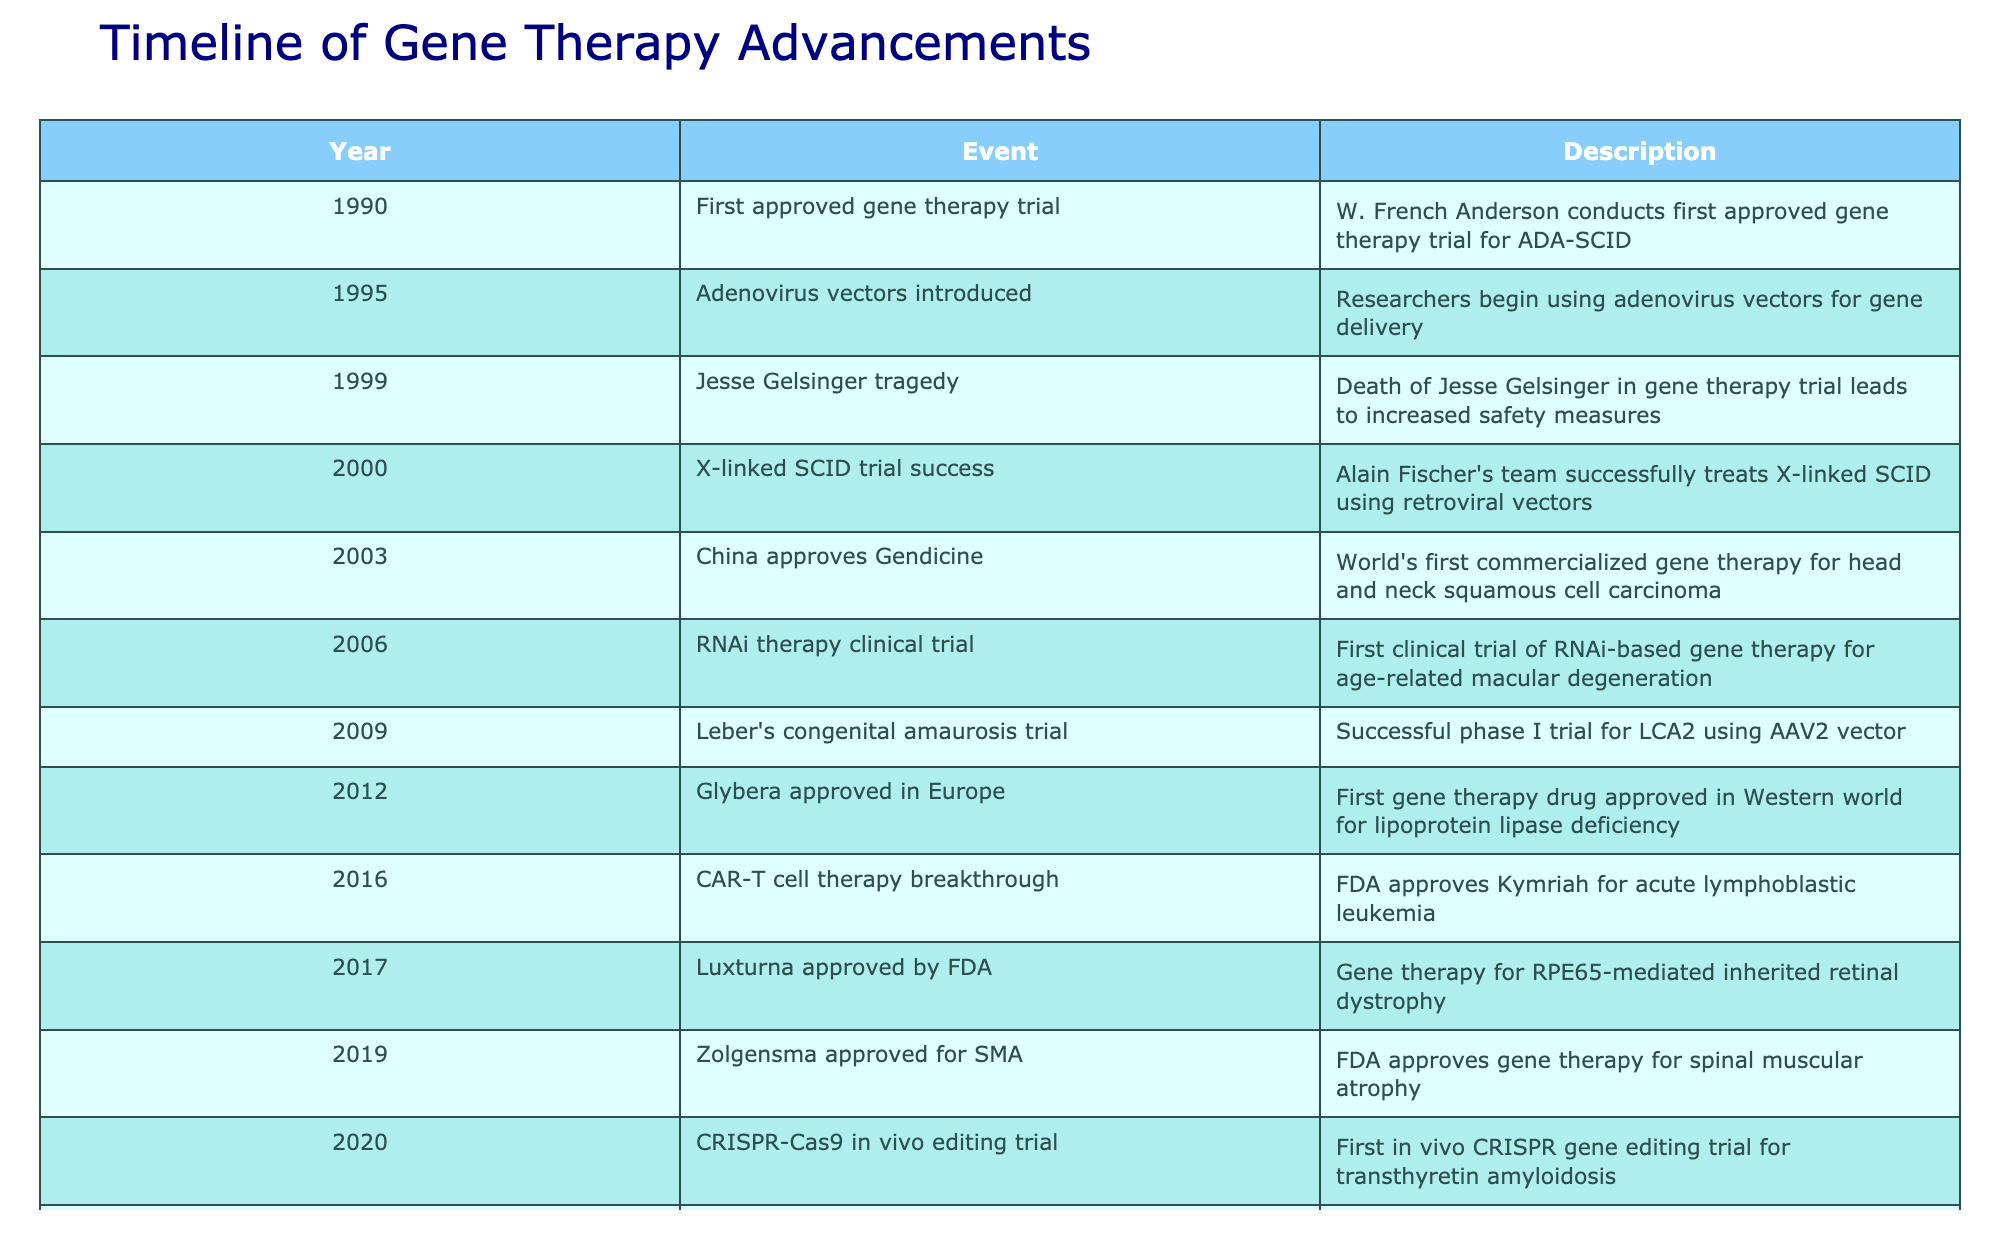What year did the first approved gene therapy trial occur? The first approved gene therapy trial occurred in 1990, as indicated in the table under the "Year" column associated with the event "First approved gene therapy trial."
Answer: 1990 Which gene therapy for retinal dystrophy was approved by the FDA in 2017? The gene therapy for RPE65-mediated inherited retinal dystrophy approved by the FDA in 2017 is Luxturna. This can be found by locating the entry for 2017 in the "Event" column.
Answer: Luxturna How many gene therapies were approved by the FDA between 2016 and 2023? From 2016 to 2023, four gene therapies were approved by the FDA: Kymriah (2016), Luxturna (2017), Zolgensma (2019), and Hemgenix (2022). Counting these events provides the total.
Answer: 4 What is the difference in years between the first gene therapy trial and the approval of the first commercialized gene therapy? The first approved gene therapy trial occurred in 1990, and the first commercialized gene therapy (Gendicine) was approved in 2003. The difference is calculated as 2003 - 1990 = 13 years.
Answer: 13 years Was there a gene therapy clinical trial for RNA interference (RNAi) before 2010? Yes, the first clinical trial of RNAi-based gene therapy for age-related macular degeneration occurred in 2006, which is before 2010. This can be confirmed by locating the relevant entry in the table.
Answer: Yes Which gene therapy was developed using a CRISPR technology and what was the trial's focus? The gene therapy developed using CRISPR technology is for transthyretin amyloidosis, and the trial was initiated in 2020, as indicated by examining the relevant row in the table.
Answer: Transthyretin amyloidosis What is the chronological order of gene therapy approvals from 2017 to 2023? The chronological order from 2017 to 2023 is: 2017 - Luxturna, 2019 - Zolgensma, 2022 - Hemgenix, and finally 2023 - BEAM-101 trial. This is achieved by looking at the years and corresponding events sequentially.
Answer: Luxturna, Zolgensma, Hemgenix, BEAM-101 trial How many significant advancements in gene therapy are recorded after 2010? From 2011 to 2023, there are a total of six significant advancements: Kymriah (2016), Luxturna (2017), Zolgensma (2019), Hemgenix (2022), BEAM-101 trial (2023), and the RNAi trial (2006 was included to show the emergence of new therapies). This can be found by filtering the years and counting entries post-2010.
Answer: 6 